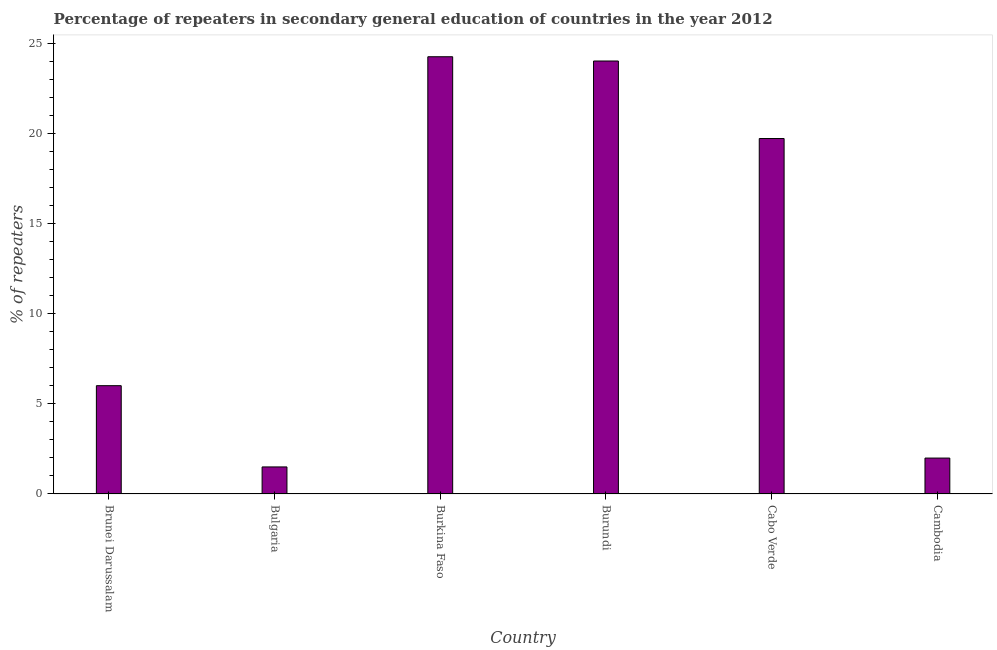Does the graph contain grids?
Ensure brevity in your answer.  No. What is the title of the graph?
Provide a succinct answer. Percentage of repeaters in secondary general education of countries in the year 2012. What is the label or title of the Y-axis?
Offer a very short reply. % of repeaters. What is the percentage of repeaters in Brunei Darussalam?
Keep it short and to the point. 6.01. Across all countries, what is the maximum percentage of repeaters?
Provide a succinct answer. 24.27. Across all countries, what is the minimum percentage of repeaters?
Make the answer very short. 1.5. In which country was the percentage of repeaters maximum?
Provide a short and direct response. Burkina Faso. What is the sum of the percentage of repeaters?
Your answer should be compact. 77.53. What is the difference between the percentage of repeaters in Bulgaria and Cabo Verde?
Your response must be concise. -18.23. What is the average percentage of repeaters per country?
Your answer should be very brief. 12.92. What is the median percentage of repeaters?
Give a very brief answer. 12.87. What is the ratio of the percentage of repeaters in Bulgaria to that in Burkina Faso?
Your answer should be very brief. 0.06. Is the percentage of repeaters in Burkina Faso less than that in Burundi?
Offer a very short reply. No. What is the difference between the highest and the second highest percentage of repeaters?
Ensure brevity in your answer.  0.24. What is the difference between the highest and the lowest percentage of repeaters?
Give a very brief answer. 22.77. In how many countries, is the percentage of repeaters greater than the average percentage of repeaters taken over all countries?
Ensure brevity in your answer.  3. What is the difference between two consecutive major ticks on the Y-axis?
Offer a very short reply. 5. Are the values on the major ticks of Y-axis written in scientific E-notation?
Give a very brief answer. No. What is the % of repeaters in Brunei Darussalam?
Your answer should be very brief. 6.01. What is the % of repeaters of Bulgaria?
Make the answer very short. 1.5. What is the % of repeaters in Burkina Faso?
Offer a very short reply. 24.27. What is the % of repeaters in Burundi?
Offer a very short reply. 24.03. What is the % of repeaters in Cabo Verde?
Give a very brief answer. 19.73. What is the % of repeaters in Cambodia?
Offer a very short reply. 1.99. What is the difference between the % of repeaters in Brunei Darussalam and Bulgaria?
Keep it short and to the point. 4.51. What is the difference between the % of repeaters in Brunei Darussalam and Burkina Faso?
Keep it short and to the point. -18.26. What is the difference between the % of repeaters in Brunei Darussalam and Burundi?
Your response must be concise. -18.02. What is the difference between the % of repeaters in Brunei Darussalam and Cabo Verde?
Keep it short and to the point. -13.72. What is the difference between the % of repeaters in Brunei Darussalam and Cambodia?
Give a very brief answer. 4.02. What is the difference between the % of repeaters in Bulgaria and Burkina Faso?
Provide a short and direct response. -22.77. What is the difference between the % of repeaters in Bulgaria and Burundi?
Give a very brief answer. -22.53. What is the difference between the % of repeaters in Bulgaria and Cabo Verde?
Provide a succinct answer. -18.23. What is the difference between the % of repeaters in Bulgaria and Cambodia?
Offer a terse response. -0.49. What is the difference between the % of repeaters in Burkina Faso and Burundi?
Your answer should be compact. 0.24. What is the difference between the % of repeaters in Burkina Faso and Cabo Verde?
Your answer should be very brief. 4.54. What is the difference between the % of repeaters in Burkina Faso and Cambodia?
Your answer should be compact. 22.28. What is the difference between the % of repeaters in Burundi and Cabo Verde?
Offer a terse response. 4.3. What is the difference between the % of repeaters in Burundi and Cambodia?
Your response must be concise. 22.04. What is the difference between the % of repeaters in Cabo Verde and Cambodia?
Provide a succinct answer. 17.74. What is the ratio of the % of repeaters in Brunei Darussalam to that in Bulgaria?
Ensure brevity in your answer.  4. What is the ratio of the % of repeaters in Brunei Darussalam to that in Burkina Faso?
Offer a very short reply. 0.25. What is the ratio of the % of repeaters in Brunei Darussalam to that in Cabo Verde?
Give a very brief answer. 0.3. What is the ratio of the % of repeaters in Brunei Darussalam to that in Cambodia?
Your response must be concise. 3.02. What is the ratio of the % of repeaters in Bulgaria to that in Burkina Faso?
Your response must be concise. 0.06. What is the ratio of the % of repeaters in Bulgaria to that in Burundi?
Offer a very short reply. 0.06. What is the ratio of the % of repeaters in Bulgaria to that in Cabo Verde?
Provide a succinct answer. 0.08. What is the ratio of the % of repeaters in Bulgaria to that in Cambodia?
Keep it short and to the point. 0.75. What is the ratio of the % of repeaters in Burkina Faso to that in Burundi?
Your answer should be compact. 1.01. What is the ratio of the % of repeaters in Burkina Faso to that in Cabo Verde?
Ensure brevity in your answer.  1.23. What is the ratio of the % of repeaters in Burkina Faso to that in Cambodia?
Keep it short and to the point. 12.18. What is the ratio of the % of repeaters in Burundi to that in Cabo Verde?
Your answer should be compact. 1.22. What is the ratio of the % of repeaters in Burundi to that in Cambodia?
Offer a very short reply. 12.06. What is the ratio of the % of repeaters in Cabo Verde to that in Cambodia?
Your answer should be compact. 9.9. 